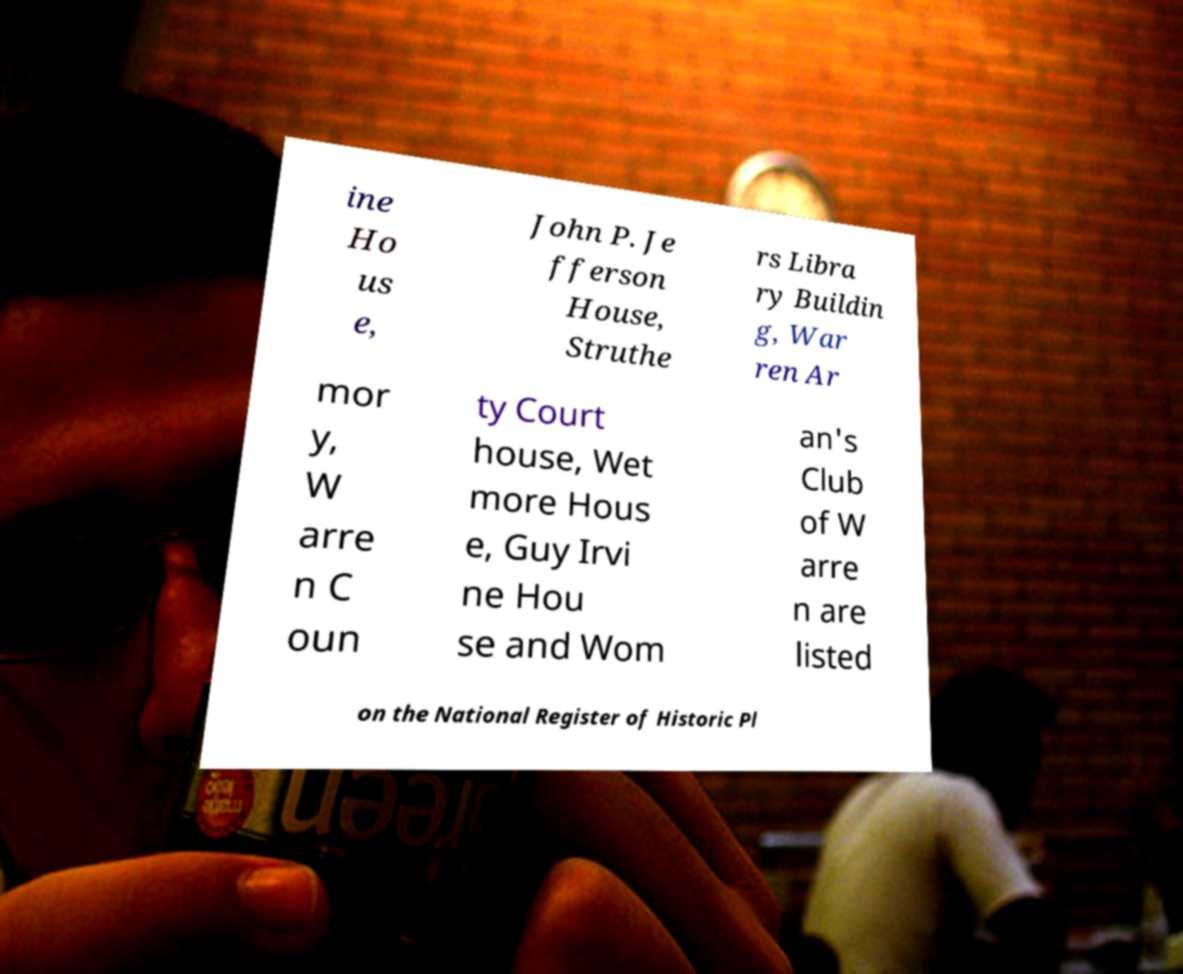Please identify and transcribe the text found in this image. ine Ho us e, John P. Je fferson House, Struthe rs Libra ry Buildin g, War ren Ar mor y, W arre n C oun ty Court house, Wet more Hous e, Guy Irvi ne Hou se and Wom an's Club of W arre n are listed on the National Register of Historic Pl 